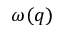Convert formula to latex. <formula><loc_0><loc_0><loc_500><loc_500>\omega ( q )</formula> 